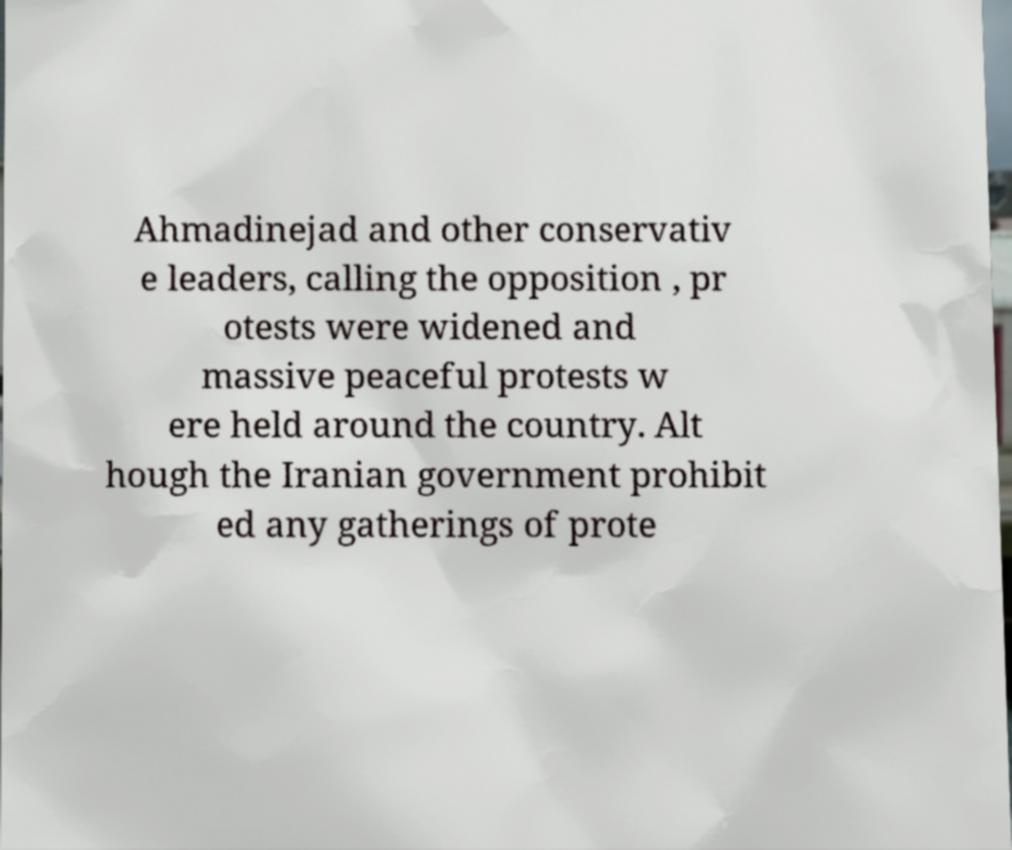Please identify and transcribe the text found in this image. Ahmadinejad and other conservativ e leaders, calling the opposition , pr otests were widened and massive peaceful protests w ere held around the country. Alt hough the Iranian government prohibit ed any gatherings of prote 